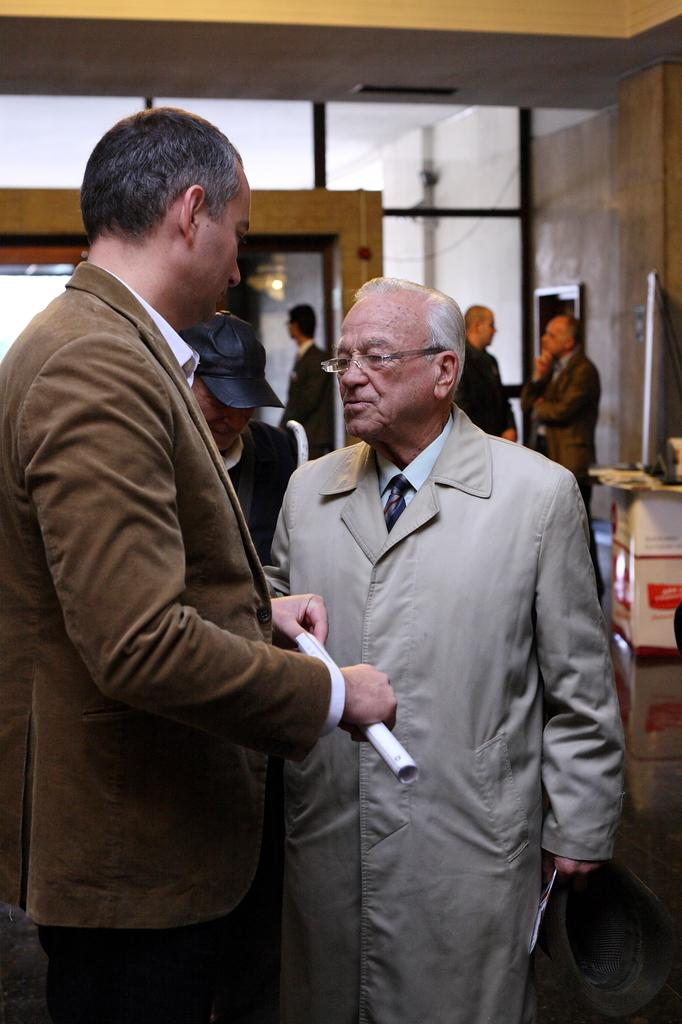How many men are in the image? There are two men in the image. What are the men holding in the image? The men are holding a cap and papers in the image. What are the men doing in the image? The men are standing and holding a cap and papers in the image. What can be seen in the background of the image? There are people, boxes, a wall, and other objects in the background of the image. Can you hear the baby crying in the image? There is no baby or crying sound present in the image. 